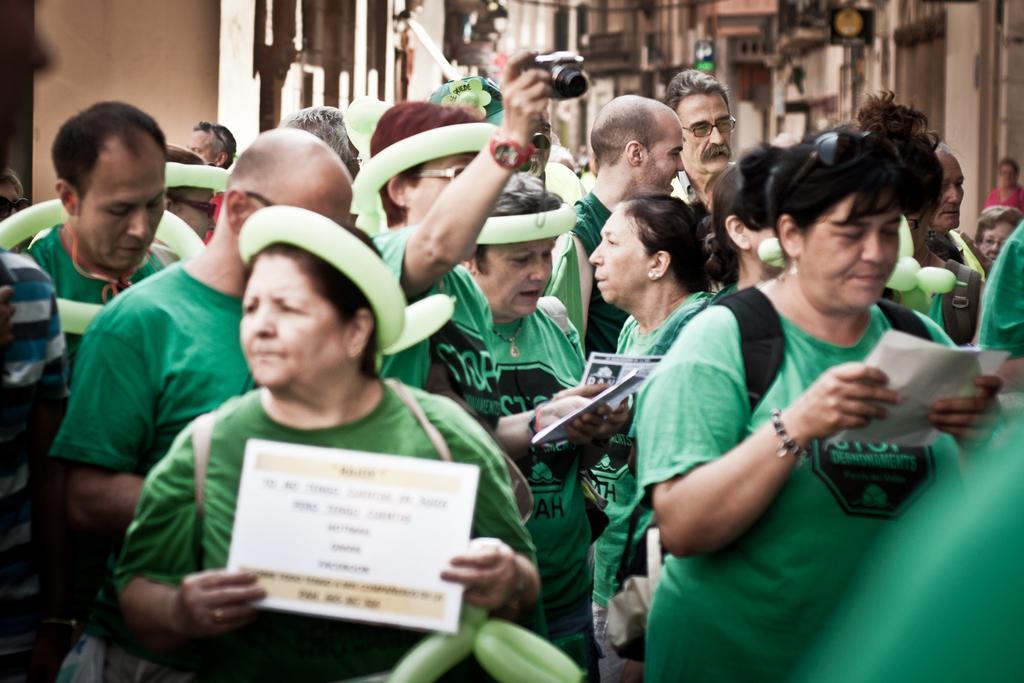Can you describe this image briefly? Here we can see group of people and they are holding papers with their hands. He is holding a camera. In the background we can see buildings and a board. 